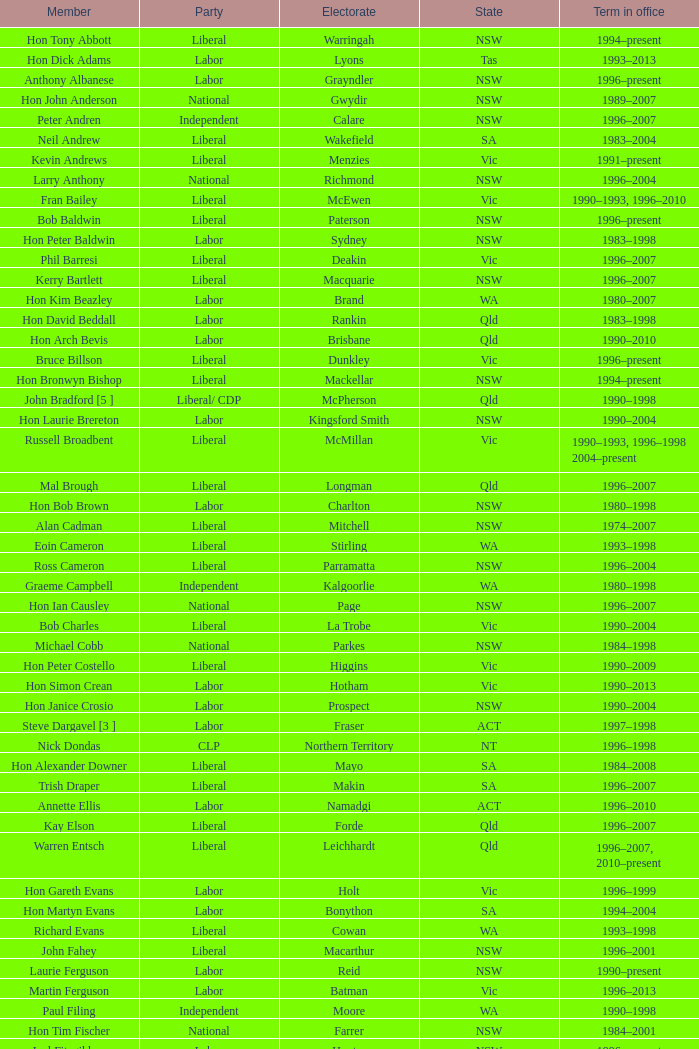The electorate was called "fowler" in what state? NSW. 